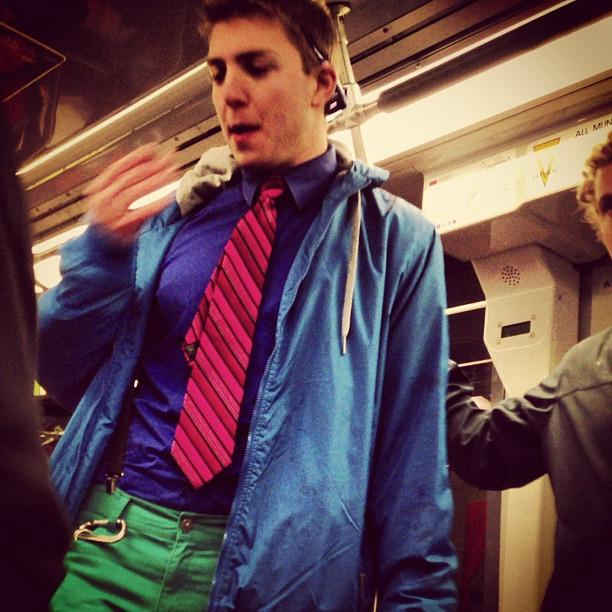What is clipped to the green pants? carabiner 